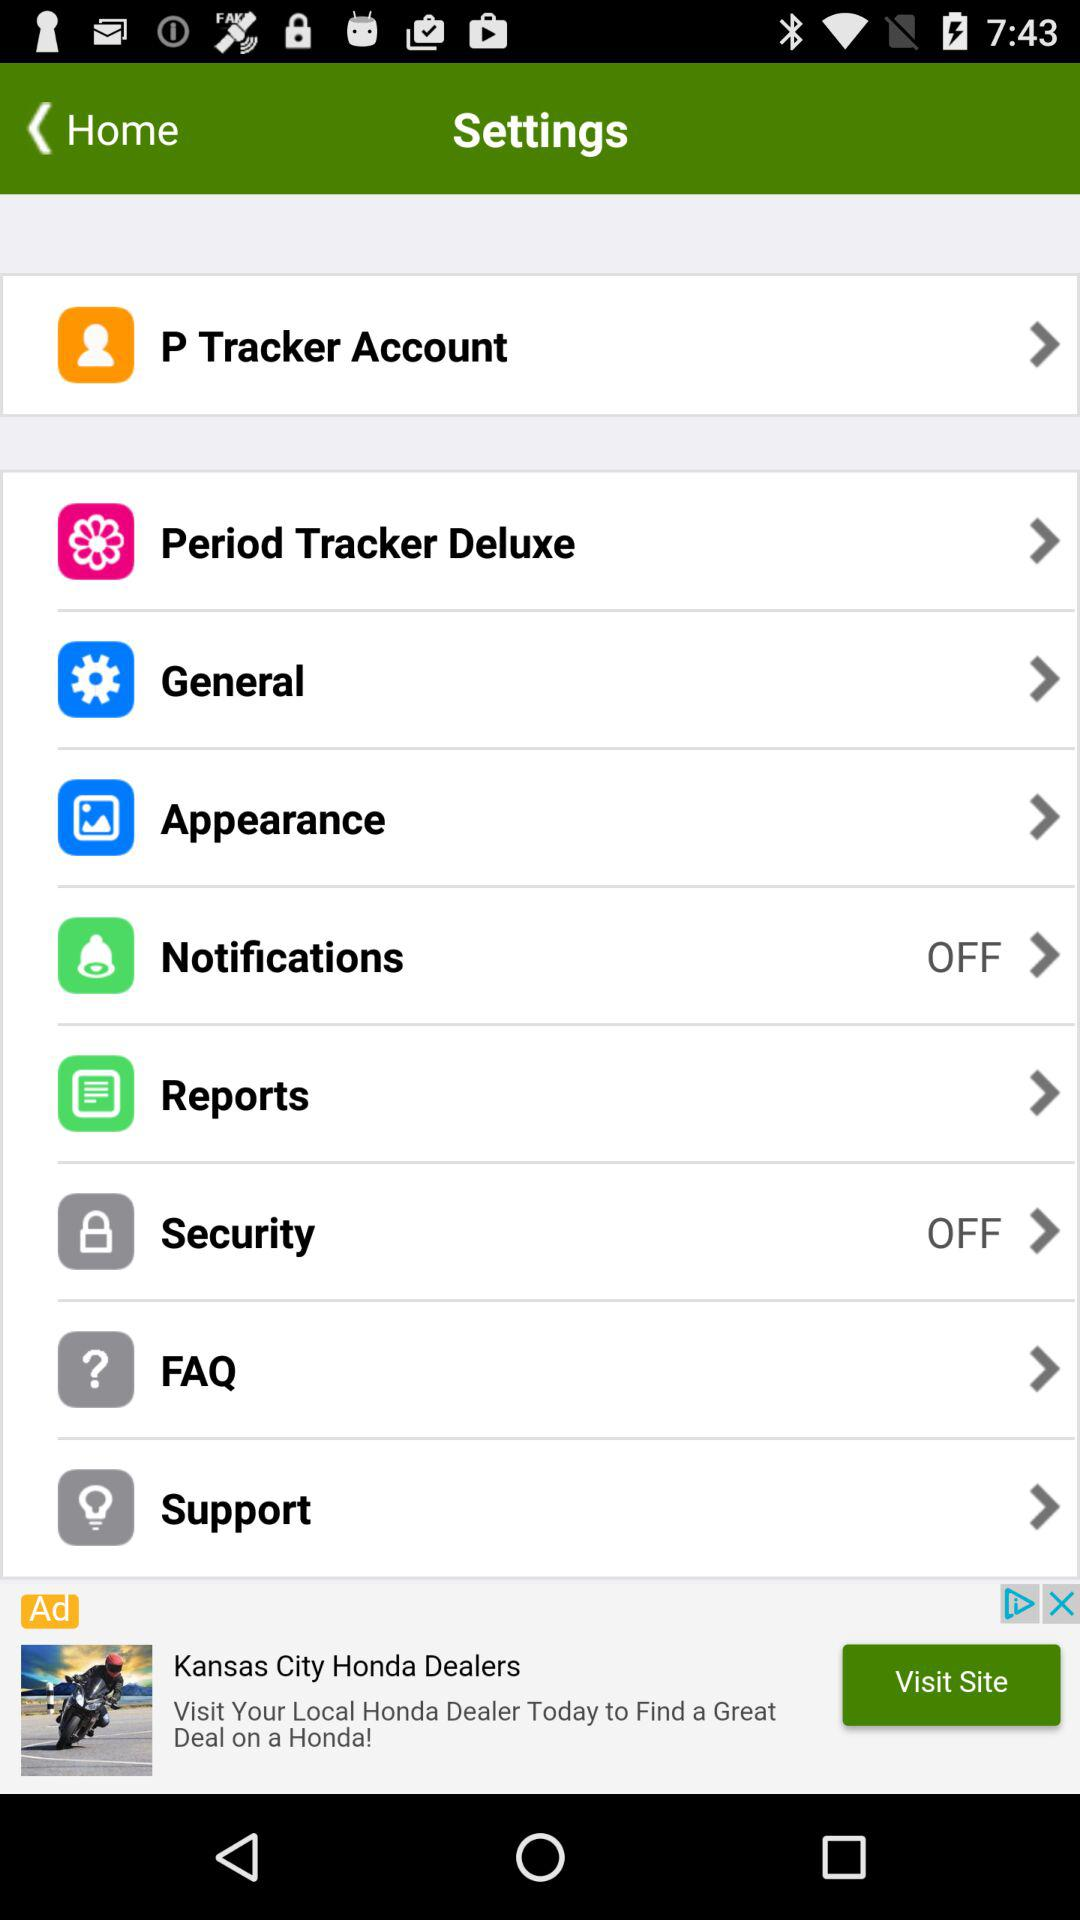What is the current status of "Notifications" settings? The current status of "Notifications" is "off". 